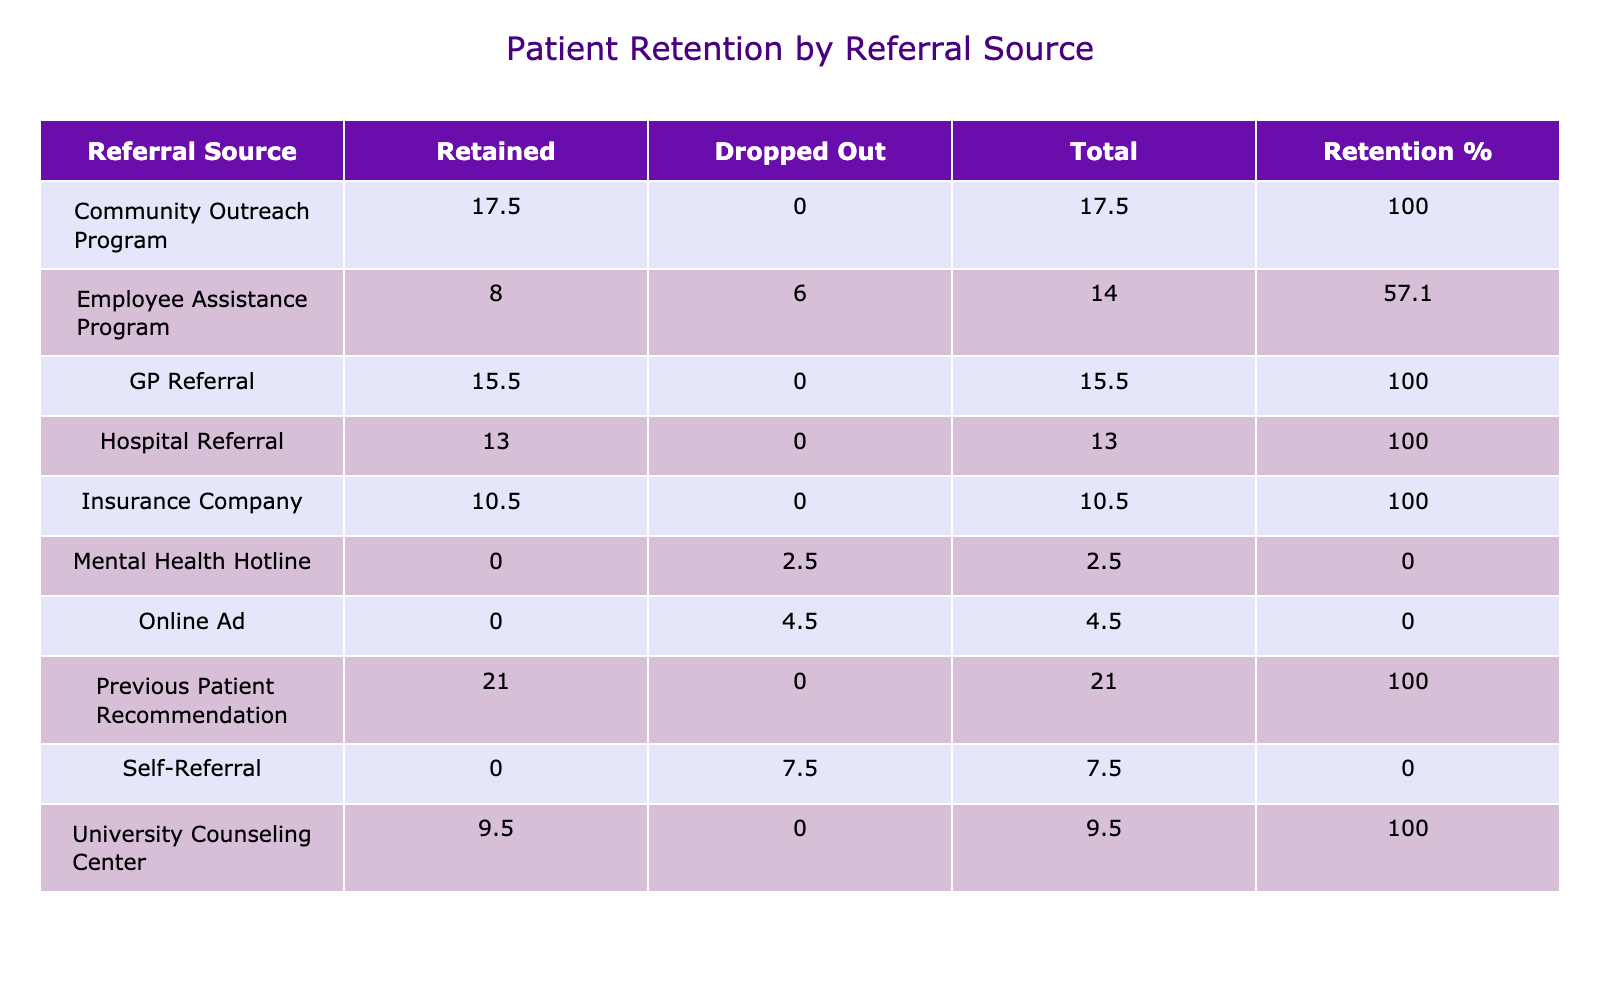What is the total number of patients referred through the Community Outreach Program? The table shows the row for the Community Outreach Program, where the total number of patients is listed in that row under the "Total" column. The value is 35.
Answer: 35 What is the Retention % for patients referred by Online Ads? Looking at the row for Online Ads, the "Retention %" column indicates the percentage of retained patients. It reads 0.0%, as no patients were retained from that source.
Answer: 0.0% How many sessions did the patients referred by Employee Assistance Programs attend on average? To find the average, we look at the "Sessions Attended" column for Employee Assistance Programs. The value is 7, as this is the only data point available for that referral source.
Answer: 7 Is it true that the highest Retention % comes from referrals made by Previous Patient Recommendations? We need to check the Retention % for all referral sources. The value for Previous Patient Recommendations is 100.0%, which is indeed the highest among all sources. Therefore, the statement is true.
Answer: Yes What is the difference in the total number of sessions attended between Hospital Referrals and GP Referrals? The total sessions attended for Hospital Referrals is 13, and for GP Referrals, it is 15. The difference is calculated as 15 - 13, which equals 2.
Answer: 2 What is the retention percentage for patients in the age group 35-44 that were referred by Self-Referral? In the table, the Self-Referral row has a "Dropped Out" count of 1 and no "Retained" patients, leading to a Retention % of 0.0% for this referral source within that age group.
Answer: 0.0% Which referral source has the least number of sessions attended overall? By checking the "Total" column values, we find that Online Ads has the least total with 5 sessions attended.
Answer: Online Ads Which age group has the highest total sessions attended from the GP Referral source? For GP Referrals, we look at the associated age groups. The only age group listed is 45-54, which has a total of 15 sessions attended. Therefore, this age group has the highest total for that source.
Answer: 45-54 What is the combined total of patients retained from the Insurance Company and Previous Patient Recommendations? The Insurance Company retained 3 patients, and Previous Patient Recommendations retained 2. We total these values: 3 + 2 = 5.
Answer: 5 How does the retention status of patients referred through the Mental Health Hotline compare with the average retention percentage across all referral sources? Mental Health Hotline has a retention percentage of 0%, while the average retention percentage across all sources can be calculated as the sum of retained patients divided by total patients. The overall ratio indicates a higher average than 0%, thus showing that Mental Health Hotline has lower retention compared to others.
Answer: Lower 